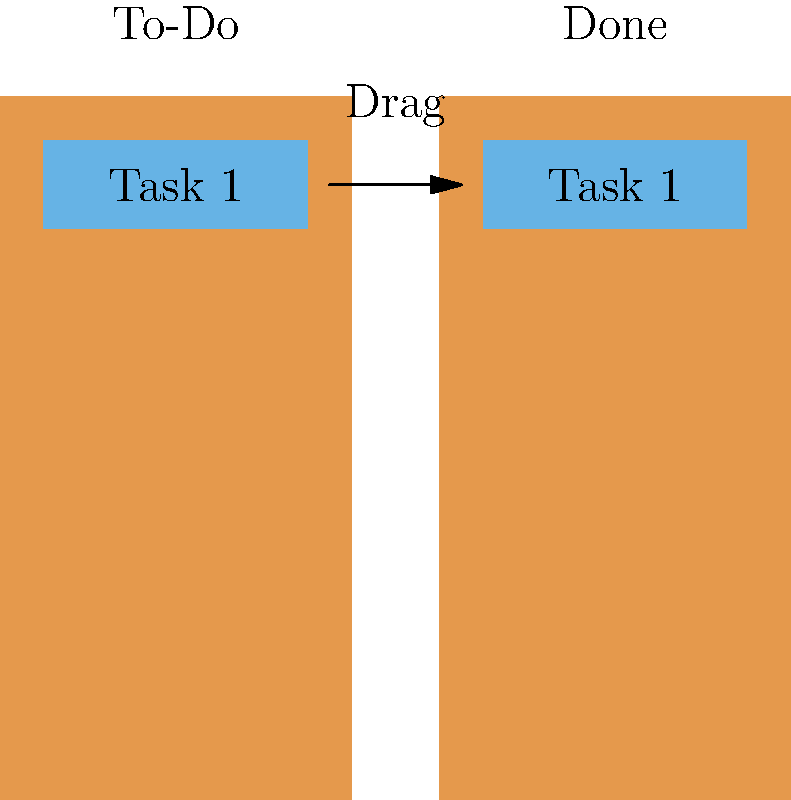In Oracle APEX, you want to implement a drag-and-drop interface for a task management feature, allowing users to move tasks from a "To-Do" list to a "Done" list. Which APEX component and associated event would you use to achieve this functionality? To implement a drag-and-drop interface in Oracle APEX for task management, follow these steps:

1. Choose the appropriate component:
   - Use the "Sortable" Interactive Grid component, which supports drag-and-drop functionality out of the box.

2. Set up the Interactive Grid:
   - Create two Interactive Grids: one for "To-Do" tasks and another for "Done" tasks.
   - Configure the grids to display task information (e.g., task name, description, due date).

3. Enable drag-and-drop:
   - In the Interactive Grid properties, enable the "Allow Reorder" option for both grids.
   - Set the "Reorder Column" to a suitable column (e.g., task order or priority).

4. Implement the drag event:
   - Use the "Row Reorder" event of the Interactive Grid to handle the drag-and-drop action.
   - In the "Row Reorder" event, write JavaScript code to:
     a. Identify the source and target grids.
     b. Update the task status in the database (e.g., from "To-Do" to "Done").
     c. Refresh both grids to reflect the changes.

5. Add custom styling (optional):
   - Use CSS to style the draggable elements and enhance the visual feedback during drag operations.

6. Test and refine:
   - Thoroughly test the drag-and-drop functionality to ensure smooth user experience and accurate data updates.

The key component for this implementation is the Interactive Grid with its "Row Reorder" event, which provides the necessary functionality for drag-and-drop operations in APEX.
Answer: Interactive Grid with Row Reorder event 